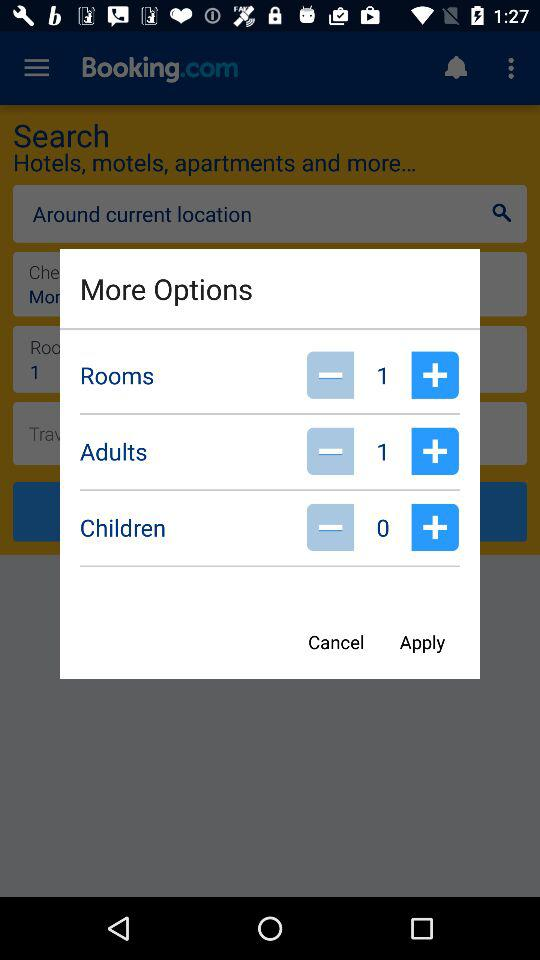How many adults are selected?
Answer the question using a single word or phrase. 1 